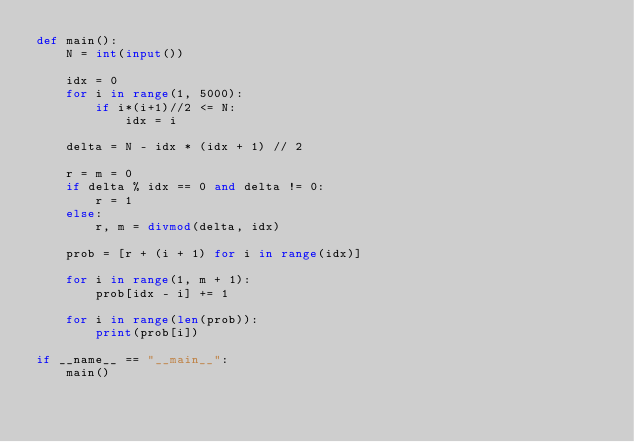<code> <loc_0><loc_0><loc_500><loc_500><_Python_>def main():
    N = int(input())

    idx = 0
    for i in range(1, 5000):
        if i*(i+1)//2 <= N:
            idx = i

    delta = N - idx * (idx + 1) // 2

    r = m = 0
    if delta % idx == 0 and delta != 0:
        r = 1
    else:
        r, m = divmod(delta, idx)

    prob = [r + (i + 1) for i in range(idx)]

    for i in range(1, m + 1):
        prob[idx - i] += 1

    for i in range(len(prob)):
        print(prob[i])

if __name__ == "__main__":
    main()</code> 